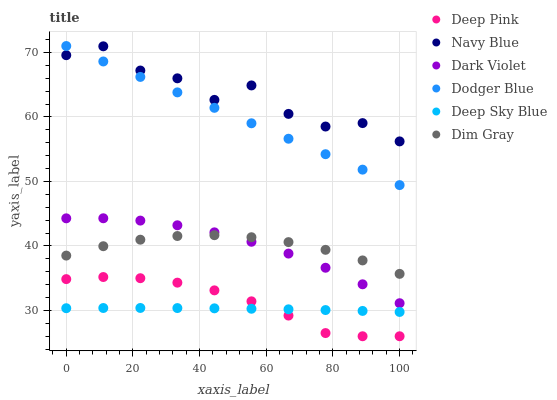Does Deep Sky Blue have the minimum area under the curve?
Answer yes or no. Yes. Does Navy Blue have the maximum area under the curve?
Answer yes or no. Yes. Does Dark Violet have the minimum area under the curve?
Answer yes or no. No. Does Dark Violet have the maximum area under the curve?
Answer yes or no. No. Is Dodger Blue the smoothest?
Answer yes or no. Yes. Is Navy Blue the roughest?
Answer yes or no. Yes. Is Dark Violet the smoothest?
Answer yes or no. No. Is Dark Violet the roughest?
Answer yes or no. No. Does Deep Pink have the lowest value?
Answer yes or no. Yes. Does Dark Violet have the lowest value?
Answer yes or no. No. Does Dodger Blue have the highest value?
Answer yes or no. Yes. Does Navy Blue have the highest value?
Answer yes or no. No. Is Deep Sky Blue less than Dodger Blue?
Answer yes or no. Yes. Is Navy Blue greater than Deep Sky Blue?
Answer yes or no. Yes. Does Navy Blue intersect Dodger Blue?
Answer yes or no. Yes. Is Navy Blue less than Dodger Blue?
Answer yes or no. No. Is Navy Blue greater than Dodger Blue?
Answer yes or no. No. Does Deep Sky Blue intersect Dodger Blue?
Answer yes or no. No. 